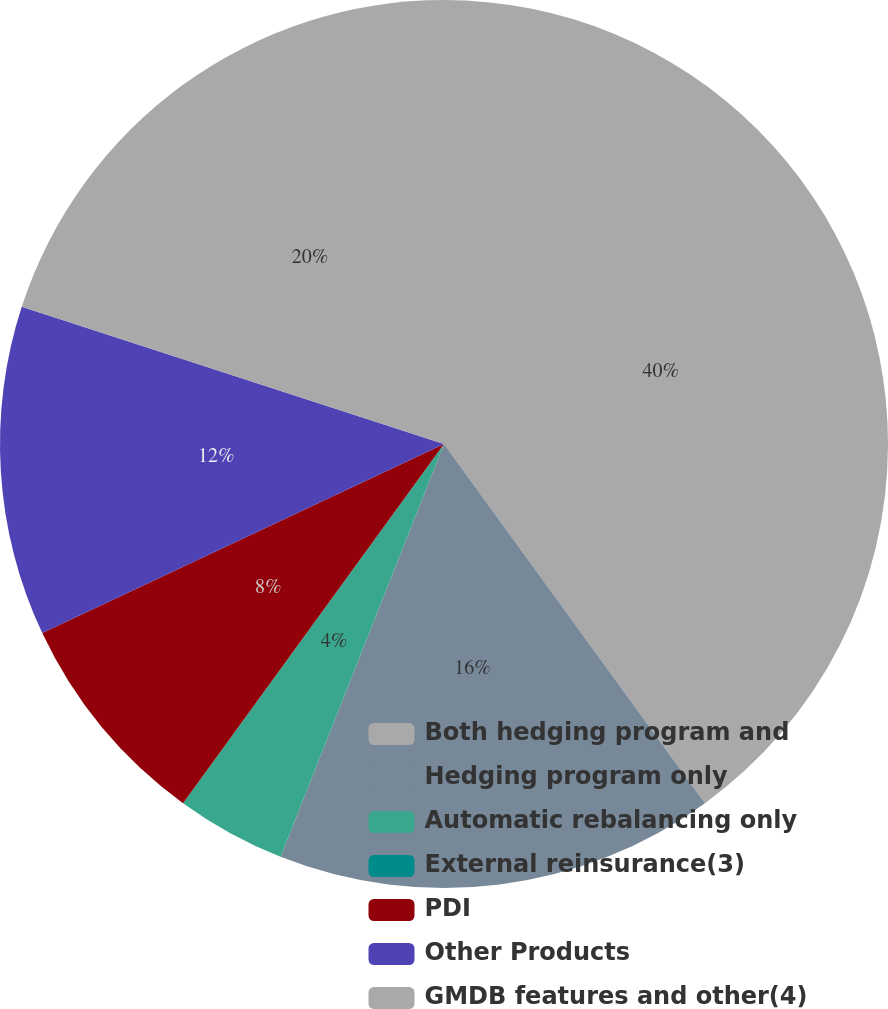<chart> <loc_0><loc_0><loc_500><loc_500><pie_chart><fcel>Both hedging program and<fcel>Hedging program only<fcel>Automatic rebalancing only<fcel>External reinsurance(3)<fcel>PDI<fcel>Other Products<fcel>GMDB features and other(4)<nl><fcel>40.0%<fcel>16.0%<fcel>4.0%<fcel>0.0%<fcel>8.0%<fcel>12.0%<fcel>20.0%<nl></chart> 